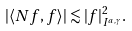Convert formula to latex. <formula><loc_0><loc_0><loc_500><loc_500>| \langle N f , f \rangle | \lesssim | f | ^ { 2 } _ { I ^ { a , \gamma } } .</formula> 